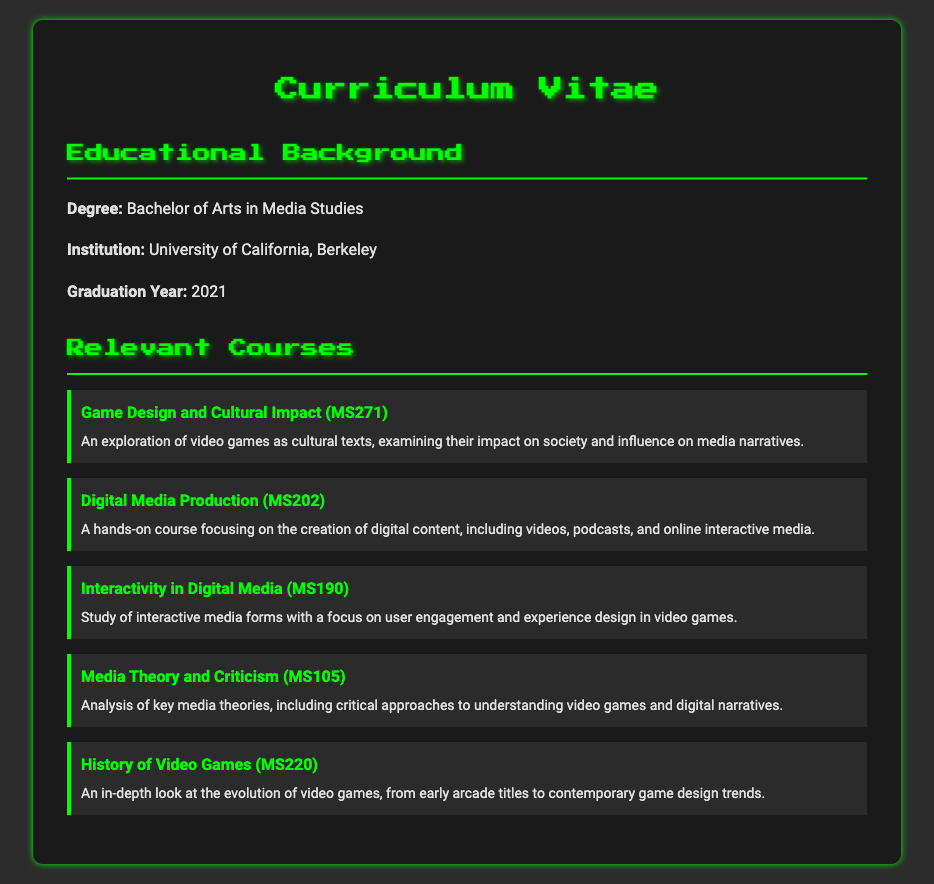What degree was earned? The degree earned is specified in the educational background section of the document.
Answer: Bachelor of Arts in Media Studies Which institution did the individual attend? The name of the institution is listed in the educational background section following the degree.
Answer: University of California, Berkeley What was the graduation year? The graduation year is provided in the educational background section.
Answer: 2021 What is the course title for MS271? The course title for MS271 is mentioned in the relevant courses section of the document.
Answer: Game Design and Cultural Impact Which course focuses on digital content creation? The course that focuses on digital content creation can be found in the relevant courses section and is designed for hands-on learning.
Answer: Digital Media Production How many relevant courses are listed? The number of relevant courses can be counted from the detailed list provided in the relevant courses section.
Answer: Five What is the focus of the course MS190? The focus of MS190 is detailed in the course description within the relevant courses section of the document.
Answer: User engagement and experience design Which course covers the history of video games? The course that covers the evolution of video games is indicated in the relevant courses section by its title and description.
Answer: History of Video Games What is the central theme of Media Theory and Criticism? The central theme of Media Theory and Criticism is outlined in the course description provided in the relevant courses section.
Answer: Understanding video games and digital narratives 